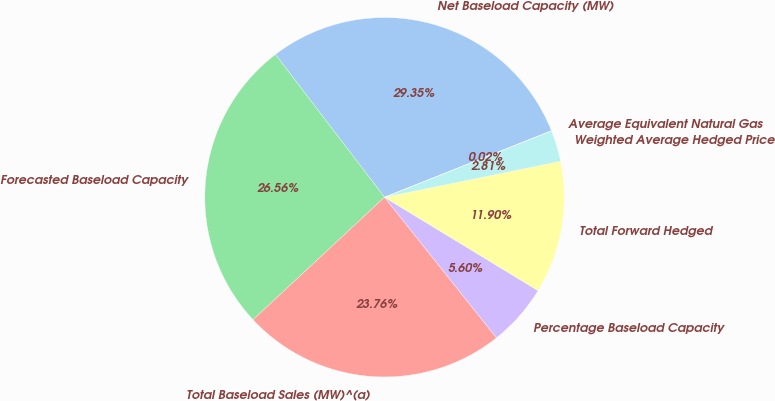Convert chart. <chart><loc_0><loc_0><loc_500><loc_500><pie_chart><fcel>Net Baseload Capacity (MW)<fcel>Forecasted Baseload Capacity<fcel>Total Baseload Sales (MW)^(a)<fcel>Percentage Baseload Capacity<fcel>Total Forward Hedged<fcel>Weighted Average Hedged Price<fcel>Average Equivalent Natural Gas<nl><fcel>29.34%<fcel>26.55%<fcel>23.76%<fcel>5.6%<fcel>11.9%<fcel>2.81%<fcel>0.02%<nl></chart> 